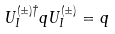<formula> <loc_0><loc_0><loc_500><loc_500>U _ { I } ^ { ( \pm ) \dagger } q U _ { I } ^ { ( \pm ) } = q</formula> 